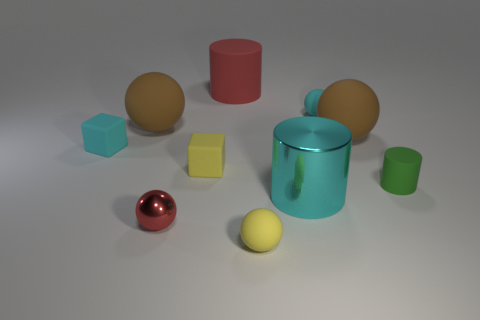There is a big red object that is made of the same material as the small cyan cube; what shape is it?
Provide a succinct answer. Cylinder. What is the shape of the red shiny object that is the same size as the cyan sphere?
Ensure brevity in your answer.  Sphere. Is there any other thing that has the same color as the tiny shiny thing?
Your answer should be very brief. Yes. The sphere that is the same material as the large cyan cylinder is what size?
Provide a short and direct response. Small. Is the shape of the green thing the same as the red object behind the cyan matte ball?
Provide a short and direct response. Yes. What size is the yellow ball?
Ensure brevity in your answer.  Small. Are there fewer red spheres that are behind the tiny green cylinder than big matte balls?
Provide a succinct answer. Yes. How many cyan matte things have the same size as the red rubber thing?
Provide a succinct answer. 0. What shape is the shiny object that is the same color as the large rubber cylinder?
Provide a short and direct response. Sphere. There is a big sphere that is on the right side of the large matte cylinder; does it have the same color as the small matte object that is on the right side of the cyan sphere?
Offer a terse response. No. 